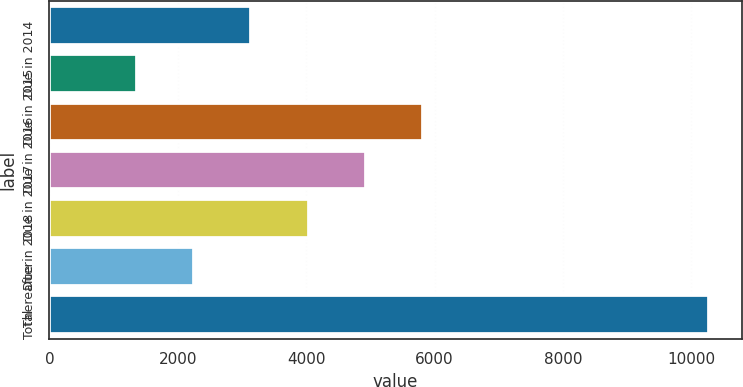<chart> <loc_0><loc_0><loc_500><loc_500><bar_chart><fcel>Due in 2014<fcel>Due in 2015<fcel>Due in 2016<fcel>Due in 2017<fcel>Due in 2018<fcel>Thereafter<fcel>Total<nl><fcel>3148.4<fcel>1368<fcel>5819<fcel>4928.8<fcel>4038.6<fcel>2258.2<fcel>10270<nl></chart> 